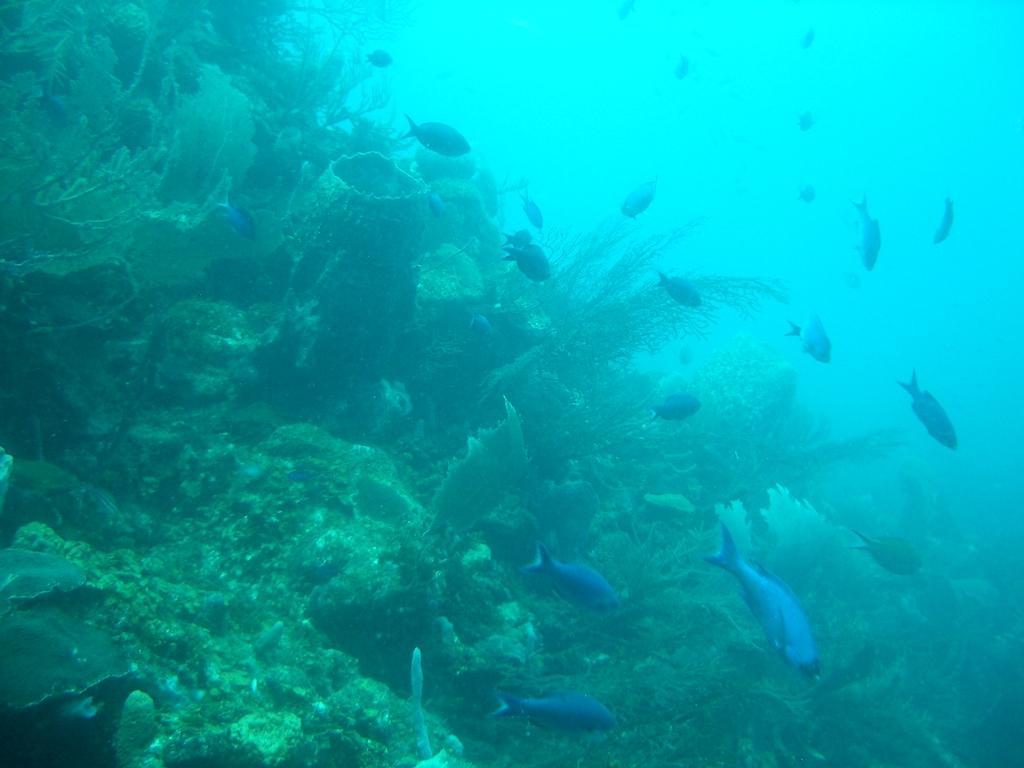How would you summarize this image in a sentence or two? This picture describes about under water environment, in this we can find few plants and fishes. 